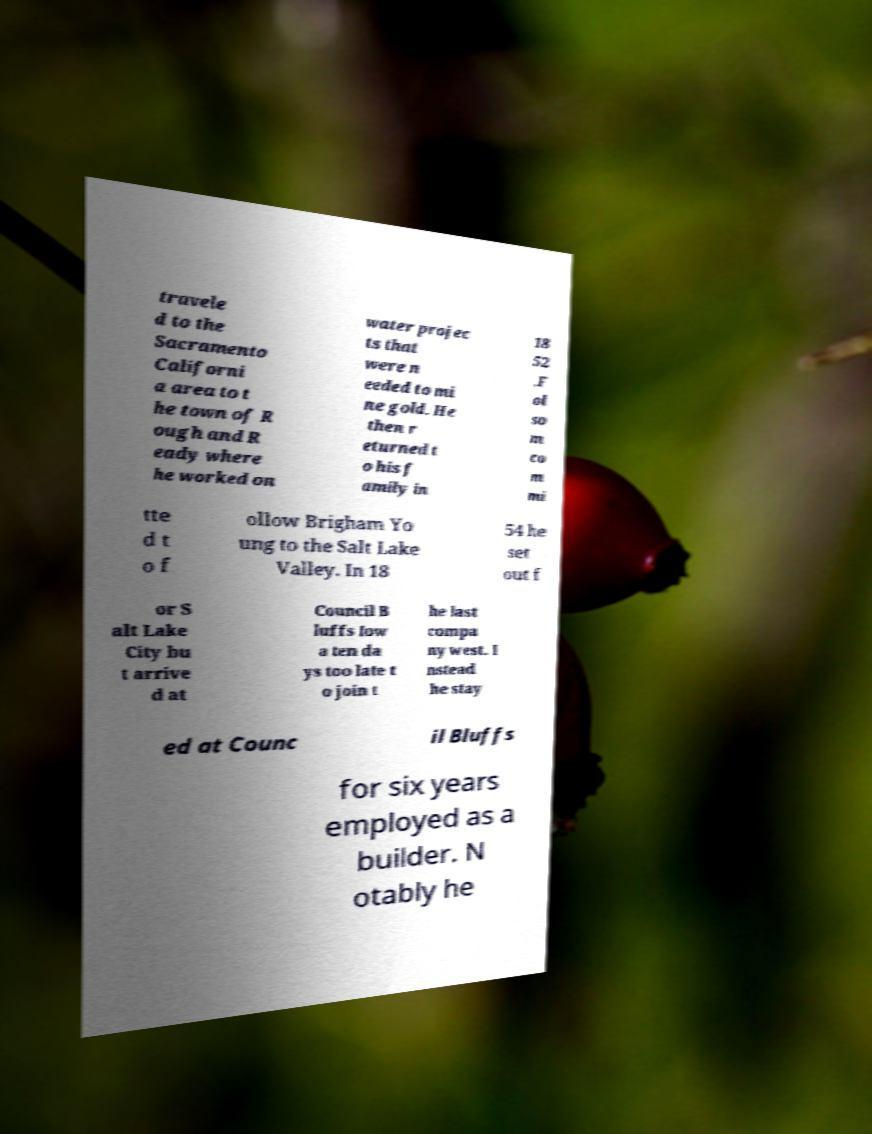Please read and relay the text visible in this image. What does it say? travele d to the Sacramento Californi a area to t he town of R ough and R eady where he worked on water projec ts that were n eeded to mi ne gold. He then r eturned t o his f amily in 18 52 .F ol so m co m mi tte d t o f ollow Brigham Yo ung to the Salt Lake Valley. In 18 54 he set out f or S alt Lake City bu t arrive d at Council B luffs Iow a ten da ys too late t o join t he last compa ny west. I nstead he stay ed at Counc il Bluffs for six years employed as a builder. N otably he 